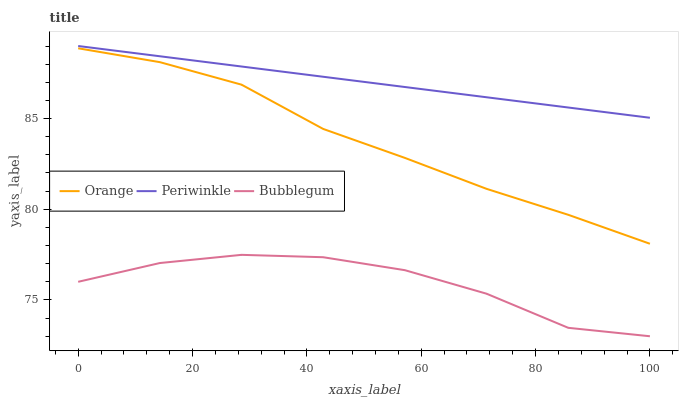Does Bubblegum have the minimum area under the curve?
Answer yes or no. Yes. Does Periwinkle have the maximum area under the curve?
Answer yes or no. Yes. Does Periwinkle have the minimum area under the curve?
Answer yes or no. No. Does Bubblegum have the maximum area under the curve?
Answer yes or no. No. Is Periwinkle the smoothest?
Answer yes or no. Yes. Is Bubblegum the roughest?
Answer yes or no. Yes. Is Bubblegum the smoothest?
Answer yes or no. No. Is Periwinkle the roughest?
Answer yes or no. No. Does Bubblegum have the lowest value?
Answer yes or no. Yes. Does Periwinkle have the lowest value?
Answer yes or no. No. Does Periwinkle have the highest value?
Answer yes or no. Yes. Does Bubblegum have the highest value?
Answer yes or no. No. Is Bubblegum less than Periwinkle?
Answer yes or no. Yes. Is Orange greater than Bubblegum?
Answer yes or no. Yes. Does Bubblegum intersect Periwinkle?
Answer yes or no. No. 